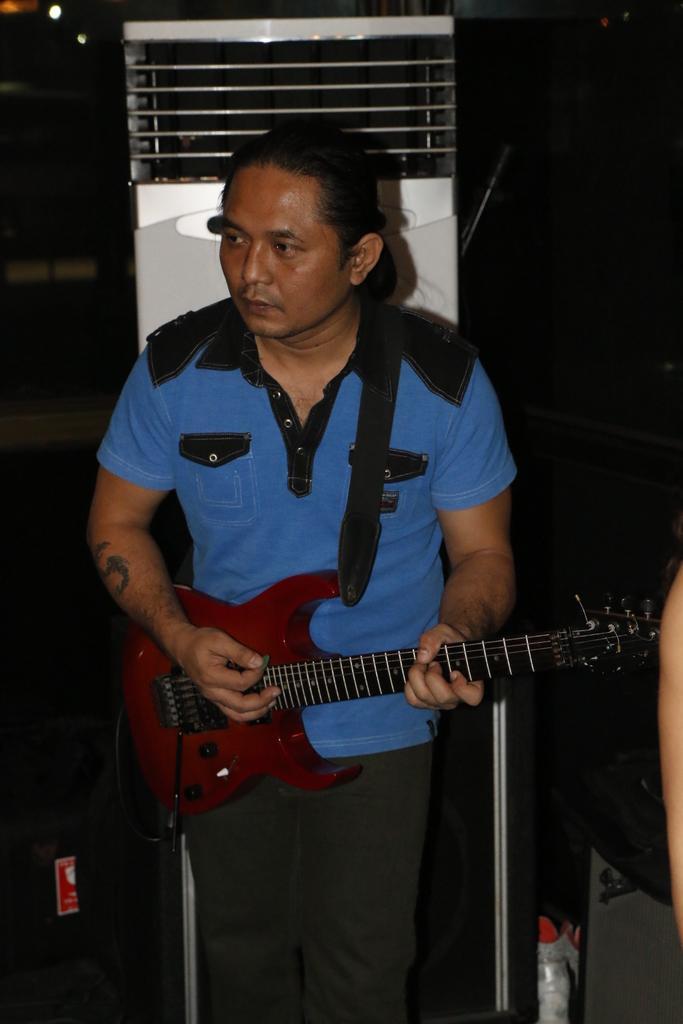How would you summarize this image in a sentence or two? In this image we can see a man wearing blue t shirt is holding a guitar in his hands and playing it. There is an air conditioner behind him. 